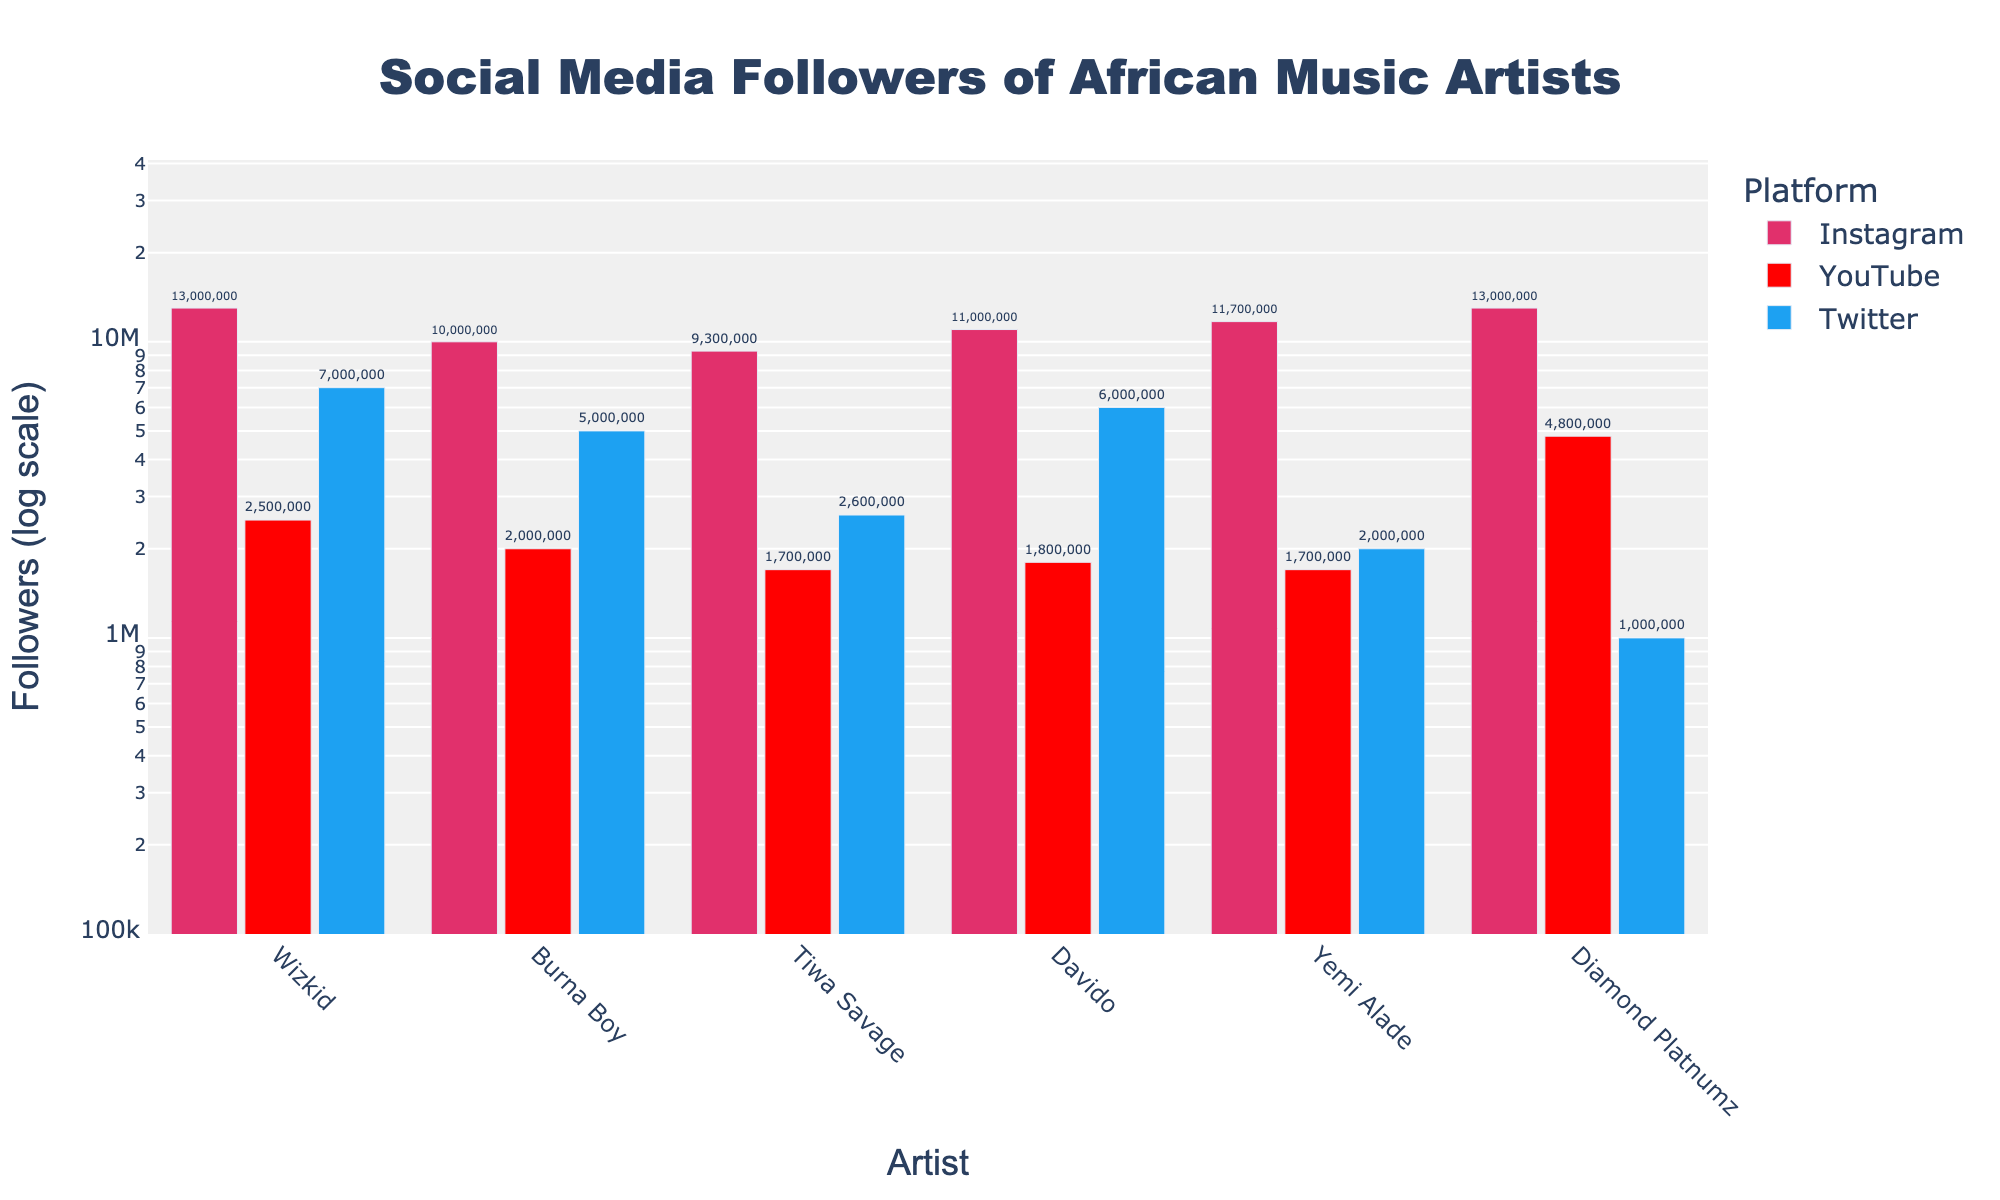What's the title of the plot? The plot's title is the text located at the top center of the figure. It provides a summarization of what the plot represents.
Answer: Social Media Followers of African Music Artists How many platforms are compared in the figure? To determine the number of platforms, count the unique text labels corresponding to different bars in the legend.
Answer: Three Which artist has the most Instagram followers? Identify the artist associated with the highest bar for the Instagram platform.
Answer: Wizkid and Diamond Platnumz How do the YouTube followers of Yemi Alade compare to those of Burna Boy? Compare the heights of the bars representing YouTube followers for Yemi Alade and Burna Boy. Yemi Alade has slightly fewer YouTube followers than Burna Boy.
Answer: Yemi Alade has fewer followers than Burna Boy What is the total number of followers for Tiwa Savage across all platforms? Sum the followers for Tiwa Savage from all three platforms (Instagram, YouTube, Twitter). 9,300,000 (Instagram) + 1,700,000 (YouTube) + 2,600,000 (Twitter) = 13,600,000.
Answer: 13,600,000 Between Davido and Burna Boy, who has more Twitter followers and by how much? Locate the bars for Twitter followers for both Davido and Burna Boy, and calculate the difference. 6,000,000 (Davido) - 5,000,000 (Burna Boy) = 1,000,000.
Answer: Davido, by 1,000,000 followers What is the range of followers on Instagram for the artists shown? Find the minimum and maximum values for Instagram followers and calculate the range. The range is 13,000,000 (max) - 9,300,000 (min) = 3,700,000 followers.
Answer: 3,700,000 Which artist has the smallest difference between their Instagram and YouTube followers? Calculate the difference between Instagram and YouTube followers for each artist and find the smallest difference. Yemi Alade's difference is 11,700,000 - 1,700,000 = 10,000,000.
Answer: Yemi Alade What is the general trend of followers across the platforms for Diamond Platnumz? Observe the height of the bars for Diamond Platnumz across Instagram, YouTube, and Twitter to identify the pattern.
Answer: High on Instagram, moderately high on YouTube, and low on Twitter 